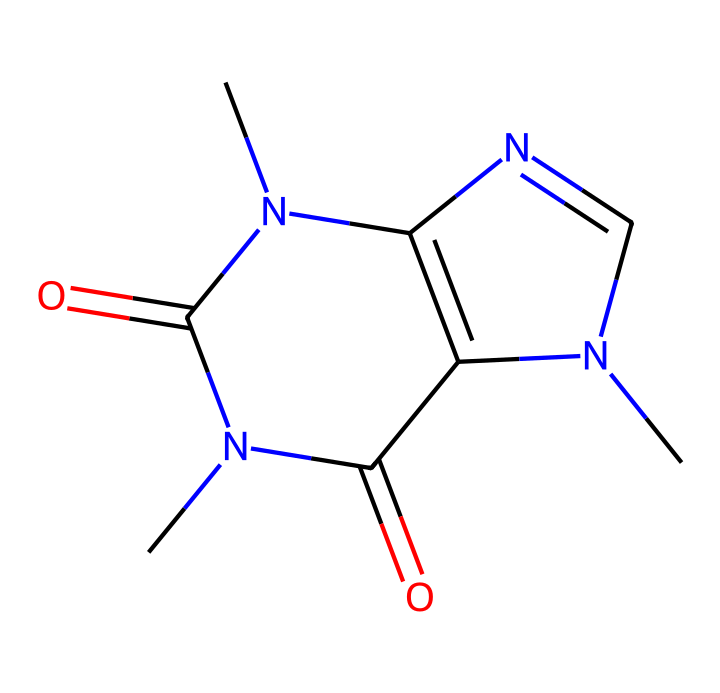What is the molecular formula of caffeine? The SMILES representation gives the structure needed to determine the molecular formula. Counting the carbon (C), hydrogen (H), nitrogen (N), and oxygen (O) atoms yields C8H10N4O2.
Answer: C8H10N4O2 How many nitrogen atoms are present in the caffeine structure? The SMILES representation contains four nitrogen (N) atoms. You can count them directly from the representation to find the total.
Answer: 4 What type of functional groups are present in caffeine? Observing the structure, you can identify amidine groups (due to the C=O and -N groups) and the presence of rings. These indicate the presence of various functional groups typical of alkaloids.
Answer: amide Does caffeine contain any oxygen atoms? The structure includes two oxygen atoms, which can be seen in the C=O parts of the structure. There are no other explicit oxygen-containing functional groups.
Answer: 2 What is the significance of nitrogen in the structure of caffeine? The nitrogen atoms influence the solubility and bioactivity of caffeine as an alkaloid, which contributes to its stimulant properties. These properties are tied directly to the presence of nitrogen in the structure.
Answer: stimulant How many ring structures are present in caffeine? By analyzing the SMILES representation, you can see there are two fused rings in the structure, making it a bicyclic compound. This is a characteristic feature of caffeine.
Answer: 2 